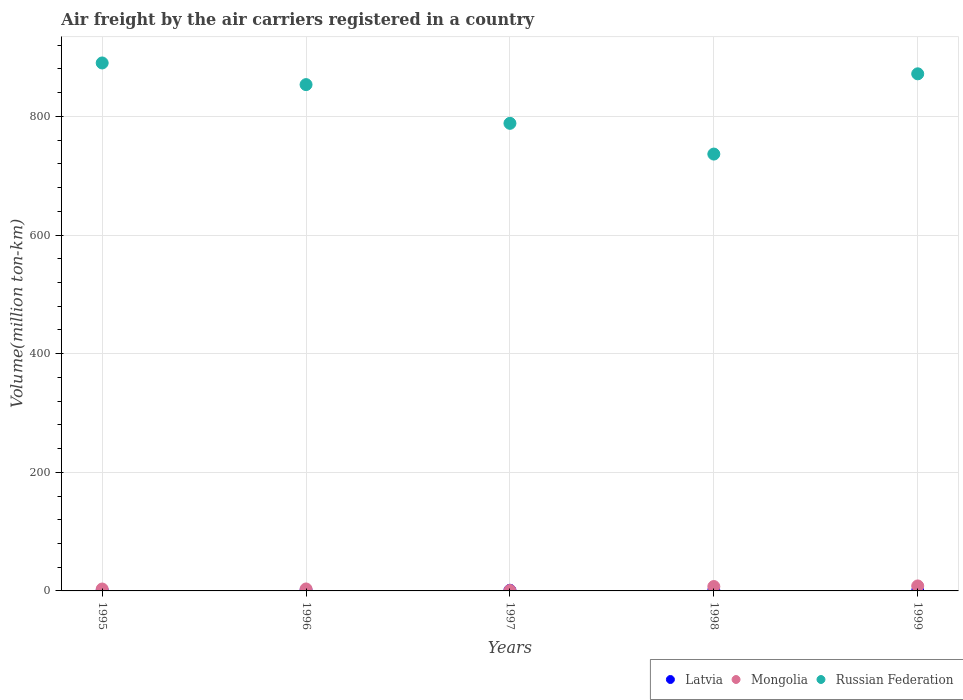Is the number of dotlines equal to the number of legend labels?
Your answer should be very brief. Yes. Across all years, what is the maximum volume of the air carriers in Mongolia?
Your response must be concise. 8.4. Across all years, what is the minimum volume of the air carriers in Mongolia?
Your response must be concise. 0.8. What is the total volume of the air carriers in Latvia in the graph?
Your response must be concise. 4.5. What is the difference between the volume of the air carriers in Mongolia in 1996 and that in 1997?
Offer a terse response. 2.5. What is the difference between the volume of the air carriers in Russian Federation in 1995 and the volume of the air carriers in Mongolia in 1997?
Your answer should be compact. 889.3. What is the average volume of the air carriers in Latvia per year?
Offer a terse response. 0.9. In the year 1996, what is the difference between the volume of the air carriers in Russian Federation and volume of the air carriers in Mongolia?
Your response must be concise. 850.3. What is the ratio of the volume of the air carriers in Latvia in 1996 to that in 1998?
Ensure brevity in your answer.  1.22. What is the difference between the highest and the lowest volume of the air carriers in Mongolia?
Offer a very short reply. 7.6. Is it the case that in every year, the sum of the volume of the air carriers in Russian Federation and volume of the air carriers in Latvia  is greater than the volume of the air carriers in Mongolia?
Make the answer very short. Yes. Are the values on the major ticks of Y-axis written in scientific E-notation?
Keep it short and to the point. No. Does the graph contain any zero values?
Offer a very short reply. No. Does the graph contain grids?
Offer a terse response. Yes. What is the title of the graph?
Ensure brevity in your answer.  Air freight by the air carriers registered in a country. What is the label or title of the X-axis?
Your answer should be compact. Years. What is the label or title of the Y-axis?
Make the answer very short. Volume(million ton-km). What is the Volume(million ton-km) in Latvia in 1995?
Provide a short and direct response. 1. What is the Volume(million ton-km) in Mongolia in 1995?
Your answer should be very brief. 3.2. What is the Volume(million ton-km) of Russian Federation in 1995?
Keep it short and to the point. 890.1. What is the Volume(million ton-km) of Latvia in 1996?
Offer a very short reply. 1.1. What is the Volume(million ton-km) of Mongolia in 1996?
Offer a terse response. 3.3. What is the Volume(million ton-km) in Russian Federation in 1996?
Your response must be concise. 853.6. What is the Volume(million ton-km) of Latvia in 1997?
Offer a terse response. 1.1. What is the Volume(million ton-km) in Mongolia in 1997?
Ensure brevity in your answer.  0.8. What is the Volume(million ton-km) in Russian Federation in 1997?
Offer a terse response. 788.3. What is the Volume(million ton-km) in Latvia in 1998?
Your answer should be very brief. 0.9. What is the Volume(million ton-km) of Mongolia in 1998?
Provide a succinct answer. 7.4. What is the Volume(million ton-km) of Russian Federation in 1998?
Your answer should be compact. 736.5. What is the Volume(million ton-km) of Latvia in 1999?
Your response must be concise. 0.4. What is the Volume(million ton-km) of Mongolia in 1999?
Provide a succinct answer. 8.4. What is the Volume(million ton-km) of Russian Federation in 1999?
Offer a terse response. 871.8. Across all years, what is the maximum Volume(million ton-km) of Latvia?
Offer a terse response. 1.1. Across all years, what is the maximum Volume(million ton-km) of Mongolia?
Offer a very short reply. 8.4. Across all years, what is the maximum Volume(million ton-km) of Russian Federation?
Give a very brief answer. 890.1. Across all years, what is the minimum Volume(million ton-km) of Latvia?
Make the answer very short. 0.4. Across all years, what is the minimum Volume(million ton-km) in Mongolia?
Give a very brief answer. 0.8. Across all years, what is the minimum Volume(million ton-km) in Russian Federation?
Keep it short and to the point. 736.5. What is the total Volume(million ton-km) of Latvia in the graph?
Ensure brevity in your answer.  4.5. What is the total Volume(million ton-km) in Mongolia in the graph?
Your response must be concise. 23.1. What is the total Volume(million ton-km) of Russian Federation in the graph?
Make the answer very short. 4140.3. What is the difference between the Volume(million ton-km) in Mongolia in 1995 and that in 1996?
Keep it short and to the point. -0.1. What is the difference between the Volume(million ton-km) of Russian Federation in 1995 and that in 1996?
Keep it short and to the point. 36.5. What is the difference between the Volume(million ton-km) in Latvia in 1995 and that in 1997?
Your answer should be compact. -0.1. What is the difference between the Volume(million ton-km) of Russian Federation in 1995 and that in 1997?
Offer a terse response. 101.8. What is the difference between the Volume(million ton-km) in Mongolia in 1995 and that in 1998?
Provide a short and direct response. -4.2. What is the difference between the Volume(million ton-km) in Russian Federation in 1995 and that in 1998?
Offer a terse response. 153.6. What is the difference between the Volume(million ton-km) in Latvia in 1995 and that in 1999?
Ensure brevity in your answer.  0.6. What is the difference between the Volume(million ton-km) of Mongolia in 1995 and that in 1999?
Offer a very short reply. -5.2. What is the difference between the Volume(million ton-km) in Russian Federation in 1995 and that in 1999?
Keep it short and to the point. 18.3. What is the difference between the Volume(million ton-km) of Latvia in 1996 and that in 1997?
Offer a terse response. 0. What is the difference between the Volume(million ton-km) of Russian Federation in 1996 and that in 1997?
Your answer should be compact. 65.3. What is the difference between the Volume(million ton-km) in Russian Federation in 1996 and that in 1998?
Your response must be concise. 117.1. What is the difference between the Volume(million ton-km) in Latvia in 1996 and that in 1999?
Provide a succinct answer. 0.7. What is the difference between the Volume(million ton-km) of Mongolia in 1996 and that in 1999?
Ensure brevity in your answer.  -5.1. What is the difference between the Volume(million ton-km) of Russian Federation in 1996 and that in 1999?
Your answer should be compact. -18.2. What is the difference between the Volume(million ton-km) in Mongolia in 1997 and that in 1998?
Provide a succinct answer. -6.6. What is the difference between the Volume(million ton-km) in Russian Federation in 1997 and that in 1998?
Your answer should be very brief. 51.8. What is the difference between the Volume(million ton-km) of Latvia in 1997 and that in 1999?
Provide a short and direct response. 0.7. What is the difference between the Volume(million ton-km) in Mongolia in 1997 and that in 1999?
Your answer should be compact. -7.6. What is the difference between the Volume(million ton-km) in Russian Federation in 1997 and that in 1999?
Make the answer very short. -83.5. What is the difference between the Volume(million ton-km) in Latvia in 1998 and that in 1999?
Provide a short and direct response. 0.5. What is the difference between the Volume(million ton-km) of Russian Federation in 1998 and that in 1999?
Your answer should be compact. -135.3. What is the difference between the Volume(million ton-km) of Latvia in 1995 and the Volume(million ton-km) of Mongolia in 1996?
Keep it short and to the point. -2.3. What is the difference between the Volume(million ton-km) of Latvia in 1995 and the Volume(million ton-km) of Russian Federation in 1996?
Provide a short and direct response. -852.6. What is the difference between the Volume(million ton-km) in Mongolia in 1995 and the Volume(million ton-km) in Russian Federation in 1996?
Your answer should be very brief. -850.4. What is the difference between the Volume(million ton-km) in Latvia in 1995 and the Volume(million ton-km) in Russian Federation in 1997?
Offer a very short reply. -787.3. What is the difference between the Volume(million ton-km) in Mongolia in 1995 and the Volume(million ton-km) in Russian Federation in 1997?
Provide a short and direct response. -785.1. What is the difference between the Volume(million ton-km) in Latvia in 1995 and the Volume(million ton-km) in Mongolia in 1998?
Offer a very short reply. -6.4. What is the difference between the Volume(million ton-km) in Latvia in 1995 and the Volume(million ton-km) in Russian Federation in 1998?
Keep it short and to the point. -735.5. What is the difference between the Volume(million ton-km) of Mongolia in 1995 and the Volume(million ton-km) of Russian Federation in 1998?
Keep it short and to the point. -733.3. What is the difference between the Volume(million ton-km) in Latvia in 1995 and the Volume(million ton-km) in Mongolia in 1999?
Your answer should be very brief. -7.4. What is the difference between the Volume(million ton-km) in Latvia in 1995 and the Volume(million ton-km) in Russian Federation in 1999?
Ensure brevity in your answer.  -870.8. What is the difference between the Volume(million ton-km) in Mongolia in 1995 and the Volume(million ton-km) in Russian Federation in 1999?
Your answer should be compact. -868.6. What is the difference between the Volume(million ton-km) in Latvia in 1996 and the Volume(million ton-km) in Russian Federation in 1997?
Give a very brief answer. -787.2. What is the difference between the Volume(million ton-km) in Mongolia in 1996 and the Volume(million ton-km) in Russian Federation in 1997?
Make the answer very short. -785. What is the difference between the Volume(million ton-km) in Latvia in 1996 and the Volume(million ton-km) in Mongolia in 1998?
Keep it short and to the point. -6.3. What is the difference between the Volume(million ton-km) of Latvia in 1996 and the Volume(million ton-km) of Russian Federation in 1998?
Provide a succinct answer. -735.4. What is the difference between the Volume(million ton-km) of Mongolia in 1996 and the Volume(million ton-km) of Russian Federation in 1998?
Provide a short and direct response. -733.2. What is the difference between the Volume(million ton-km) in Latvia in 1996 and the Volume(million ton-km) in Mongolia in 1999?
Your answer should be compact. -7.3. What is the difference between the Volume(million ton-km) in Latvia in 1996 and the Volume(million ton-km) in Russian Federation in 1999?
Keep it short and to the point. -870.7. What is the difference between the Volume(million ton-km) in Mongolia in 1996 and the Volume(million ton-km) in Russian Federation in 1999?
Offer a very short reply. -868.5. What is the difference between the Volume(million ton-km) in Latvia in 1997 and the Volume(million ton-km) in Mongolia in 1998?
Ensure brevity in your answer.  -6.3. What is the difference between the Volume(million ton-km) of Latvia in 1997 and the Volume(million ton-km) of Russian Federation in 1998?
Ensure brevity in your answer.  -735.4. What is the difference between the Volume(million ton-km) in Mongolia in 1997 and the Volume(million ton-km) in Russian Federation in 1998?
Ensure brevity in your answer.  -735.7. What is the difference between the Volume(million ton-km) in Latvia in 1997 and the Volume(million ton-km) in Russian Federation in 1999?
Your answer should be very brief. -870.7. What is the difference between the Volume(million ton-km) of Mongolia in 1997 and the Volume(million ton-km) of Russian Federation in 1999?
Your answer should be compact. -871. What is the difference between the Volume(million ton-km) in Latvia in 1998 and the Volume(million ton-km) in Mongolia in 1999?
Give a very brief answer. -7.5. What is the difference between the Volume(million ton-km) of Latvia in 1998 and the Volume(million ton-km) of Russian Federation in 1999?
Ensure brevity in your answer.  -870.9. What is the difference between the Volume(million ton-km) of Mongolia in 1998 and the Volume(million ton-km) of Russian Federation in 1999?
Your answer should be compact. -864.4. What is the average Volume(million ton-km) of Mongolia per year?
Keep it short and to the point. 4.62. What is the average Volume(million ton-km) in Russian Federation per year?
Keep it short and to the point. 828.06. In the year 1995, what is the difference between the Volume(million ton-km) in Latvia and Volume(million ton-km) in Russian Federation?
Your answer should be very brief. -889.1. In the year 1995, what is the difference between the Volume(million ton-km) in Mongolia and Volume(million ton-km) in Russian Federation?
Provide a succinct answer. -886.9. In the year 1996, what is the difference between the Volume(million ton-km) in Latvia and Volume(million ton-km) in Mongolia?
Ensure brevity in your answer.  -2.2. In the year 1996, what is the difference between the Volume(million ton-km) in Latvia and Volume(million ton-km) in Russian Federation?
Offer a terse response. -852.5. In the year 1996, what is the difference between the Volume(million ton-km) in Mongolia and Volume(million ton-km) in Russian Federation?
Make the answer very short. -850.3. In the year 1997, what is the difference between the Volume(million ton-km) of Latvia and Volume(million ton-km) of Russian Federation?
Ensure brevity in your answer.  -787.2. In the year 1997, what is the difference between the Volume(million ton-km) in Mongolia and Volume(million ton-km) in Russian Federation?
Your answer should be compact. -787.5. In the year 1998, what is the difference between the Volume(million ton-km) of Latvia and Volume(million ton-km) of Mongolia?
Your answer should be very brief. -6.5. In the year 1998, what is the difference between the Volume(million ton-km) of Latvia and Volume(million ton-km) of Russian Federation?
Your answer should be compact. -735.6. In the year 1998, what is the difference between the Volume(million ton-km) in Mongolia and Volume(million ton-km) in Russian Federation?
Keep it short and to the point. -729.1. In the year 1999, what is the difference between the Volume(million ton-km) in Latvia and Volume(million ton-km) in Russian Federation?
Ensure brevity in your answer.  -871.4. In the year 1999, what is the difference between the Volume(million ton-km) of Mongolia and Volume(million ton-km) of Russian Federation?
Offer a terse response. -863.4. What is the ratio of the Volume(million ton-km) in Latvia in 1995 to that in 1996?
Your response must be concise. 0.91. What is the ratio of the Volume(million ton-km) in Mongolia in 1995 to that in 1996?
Make the answer very short. 0.97. What is the ratio of the Volume(million ton-km) in Russian Federation in 1995 to that in 1996?
Provide a short and direct response. 1.04. What is the ratio of the Volume(million ton-km) of Mongolia in 1995 to that in 1997?
Make the answer very short. 4. What is the ratio of the Volume(million ton-km) in Russian Federation in 1995 to that in 1997?
Give a very brief answer. 1.13. What is the ratio of the Volume(million ton-km) of Mongolia in 1995 to that in 1998?
Your answer should be very brief. 0.43. What is the ratio of the Volume(million ton-km) of Russian Federation in 1995 to that in 1998?
Provide a succinct answer. 1.21. What is the ratio of the Volume(million ton-km) of Mongolia in 1995 to that in 1999?
Your response must be concise. 0.38. What is the ratio of the Volume(million ton-km) of Mongolia in 1996 to that in 1997?
Your answer should be very brief. 4.12. What is the ratio of the Volume(million ton-km) in Russian Federation in 1996 to that in 1997?
Make the answer very short. 1.08. What is the ratio of the Volume(million ton-km) in Latvia in 1996 to that in 1998?
Offer a very short reply. 1.22. What is the ratio of the Volume(million ton-km) of Mongolia in 1996 to that in 1998?
Keep it short and to the point. 0.45. What is the ratio of the Volume(million ton-km) in Russian Federation in 1996 to that in 1998?
Give a very brief answer. 1.16. What is the ratio of the Volume(million ton-km) in Latvia in 1996 to that in 1999?
Give a very brief answer. 2.75. What is the ratio of the Volume(million ton-km) in Mongolia in 1996 to that in 1999?
Ensure brevity in your answer.  0.39. What is the ratio of the Volume(million ton-km) in Russian Federation in 1996 to that in 1999?
Ensure brevity in your answer.  0.98. What is the ratio of the Volume(million ton-km) of Latvia in 1997 to that in 1998?
Give a very brief answer. 1.22. What is the ratio of the Volume(million ton-km) of Mongolia in 1997 to that in 1998?
Your response must be concise. 0.11. What is the ratio of the Volume(million ton-km) in Russian Federation in 1997 to that in 1998?
Your answer should be compact. 1.07. What is the ratio of the Volume(million ton-km) in Latvia in 1997 to that in 1999?
Keep it short and to the point. 2.75. What is the ratio of the Volume(million ton-km) in Mongolia in 1997 to that in 1999?
Provide a short and direct response. 0.1. What is the ratio of the Volume(million ton-km) of Russian Federation in 1997 to that in 1999?
Provide a succinct answer. 0.9. What is the ratio of the Volume(million ton-km) of Latvia in 1998 to that in 1999?
Keep it short and to the point. 2.25. What is the ratio of the Volume(million ton-km) of Mongolia in 1998 to that in 1999?
Give a very brief answer. 0.88. What is the ratio of the Volume(million ton-km) in Russian Federation in 1998 to that in 1999?
Make the answer very short. 0.84. What is the difference between the highest and the second highest Volume(million ton-km) of Latvia?
Provide a short and direct response. 0. What is the difference between the highest and the lowest Volume(million ton-km) of Latvia?
Ensure brevity in your answer.  0.7. What is the difference between the highest and the lowest Volume(million ton-km) in Russian Federation?
Your answer should be very brief. 153.6. 